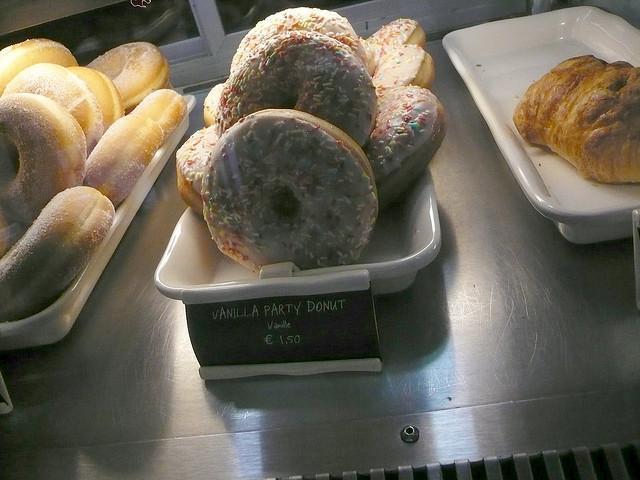How many of these donuts is it healthy to eat?
Give a very brief answer. 0. How many pastries on the right tray?
Give a very brief answer. 1. How many donuts are in the picture?
Give a very brief answer. 11. 